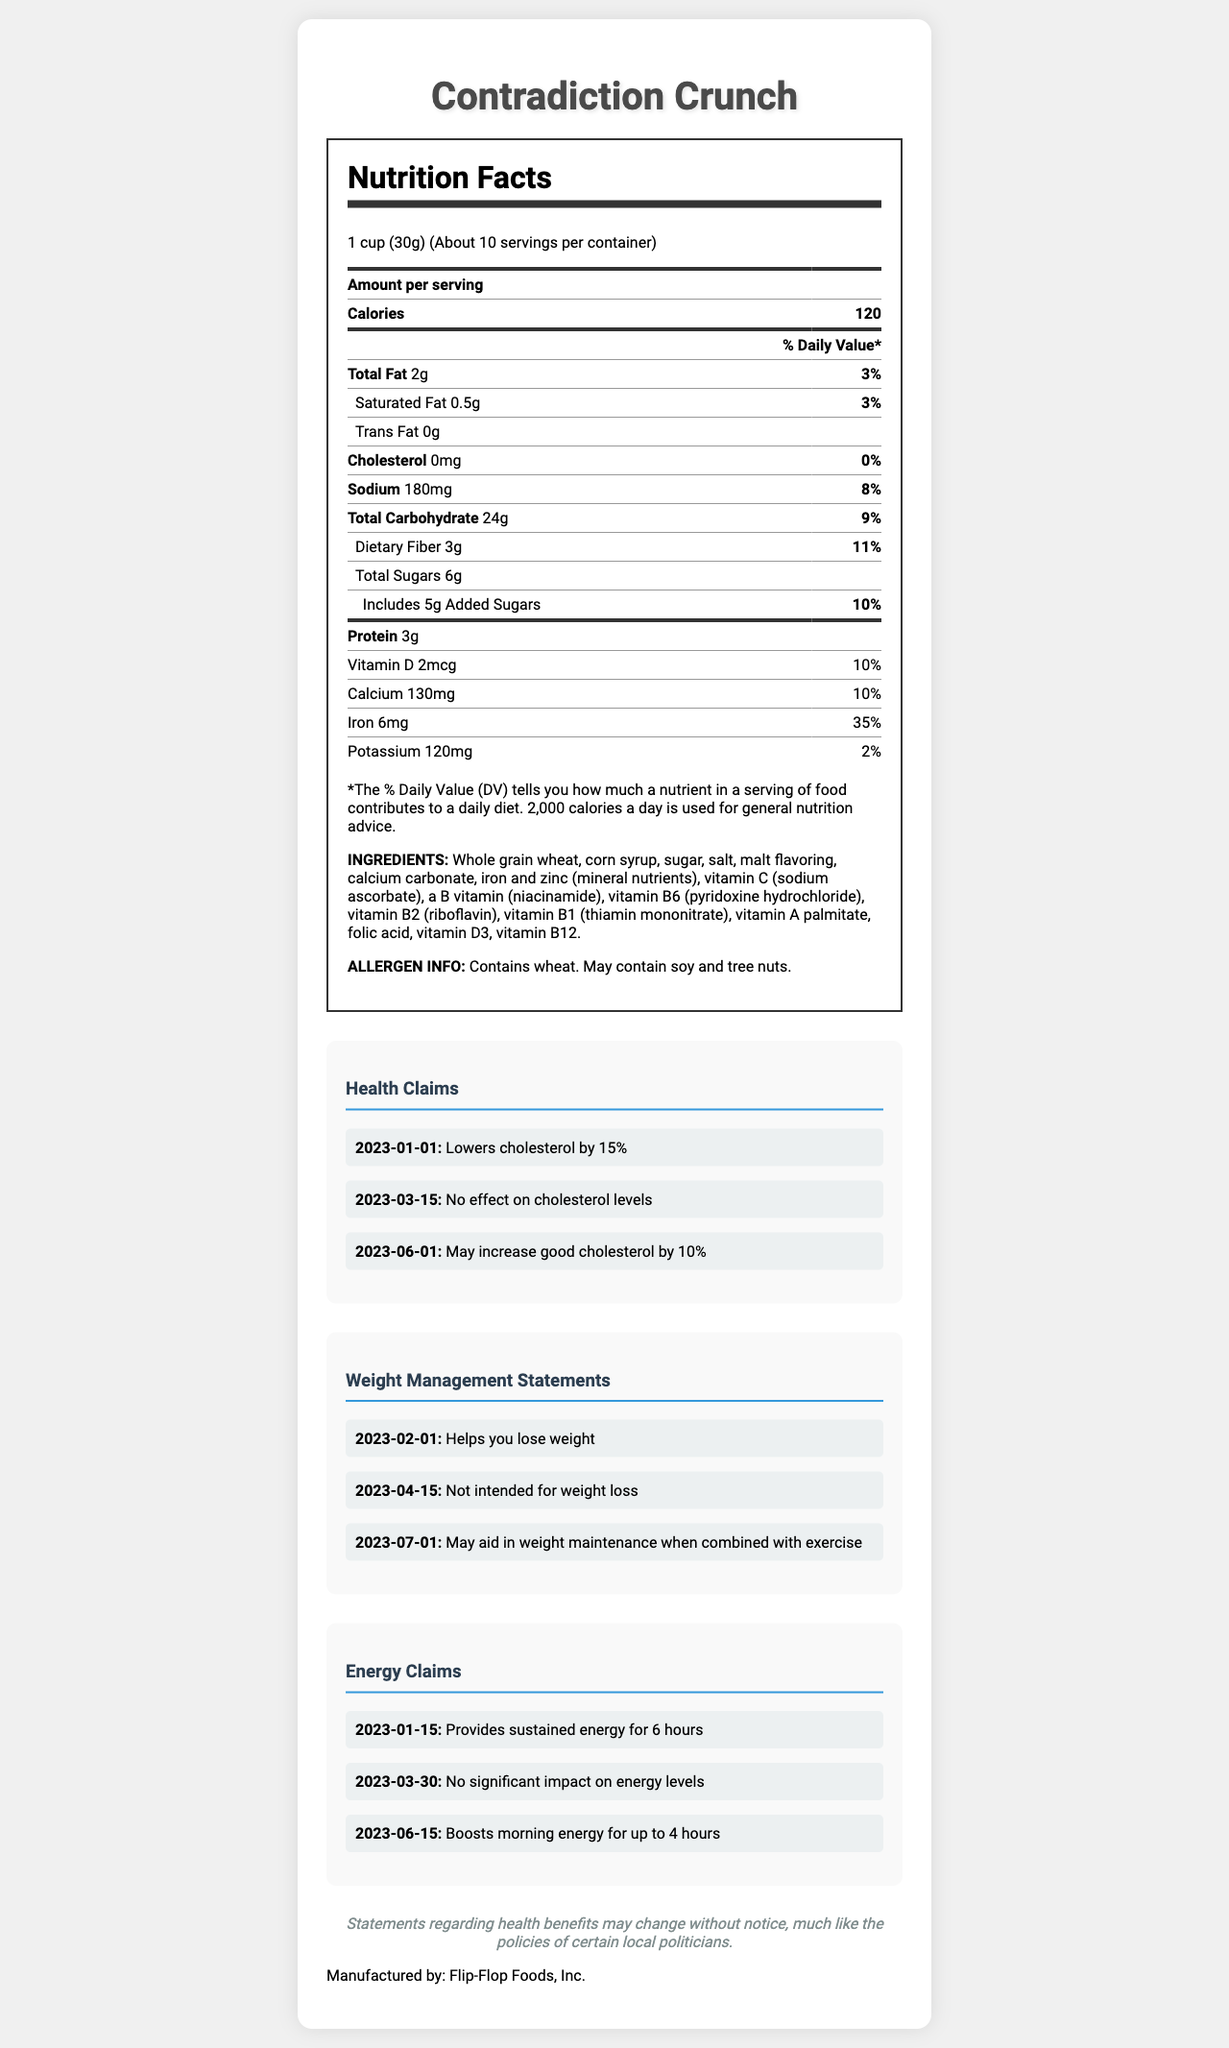what is the serving size of Contradiction Crunch? The serving size is stated in the first section of the nutrition facts, which mentions "1 cup (30g)".
Answer: 1 cup (30g) how many total calories are in one serving? The document specifies that there are 120 calories per serving.
Answer: 120 how many servings are in the container? The serving information states that there are "About 10" servings per container.
Answer: About 10 what is the amount of added sugars per serving? The nutrition label lists 5g as the amount of added sugars per serving.
Answer: 5g what is the daily value percentage of iron per serving? The daily value percentage for iron is listed as 35%.
Answer: 35% does the cereal contain any common allergens? The allergen info states that the cereal contains wheat and may contain soy and tree nuts.
Answer: Yes list all the vitamins and minerals mentioned on the label The vitamins and minerals listed under the nutrition facts are Vitamin D, Calcium, Iron, and Potassium.
Answer: Vitamin D, Calcium, Iron, Potassium what is the range of health claims made throughout the document? The document lists health claims ranging from "Lowers cholesterol by 15%" to "May increase good cholesterol by 10%".
Answer: Lowers cholesterol by 15% to May increase good cholesterol by 10% how has the manufacturer's energy claim changed over time? A. Provides sustained energy for 6 hours to Boosts morning energy for up to 4 hours B. No effect on energy levels to Provides sustained energy for 6 hours C. Boosts morning energy for up to 4 hours to Provides sustained energy for 6 hours The claims transitioned from "Provides sustained energy for 6 hours" (2023-01-15) to "No significant impact on energy levels" (2023-03-30) and then to "Boosts morning energy for up to 4 hours" (2023-06-15).
Answer: A which of the following statements is a weight management claim made in April 2023? i. Helps you lose weight ii. Not intended for weight loss iii. May aid in weight maintenance when combined with exercise The weight management claim made in April 2023 is "Not intended for weight loss".
Answer: ii does the cereal help reduce cholesterol? The health claims are contradictory, with statements claiming it "Lowers cholesterol by 15%", "No effect on cholesterol levels", and "May increase good cholesterol by 10%".
Answer: Cannot be determined is there any cholesterol in the cereal? The nutrition label states that there is 0mg of cholesterol per serving.
Answer: No summarize the main points of the Contradiction Crunch nutrition facts label The summary covers the main nutritional contents, changing claims about health benefits, allergens, manufacturer, and disclaimer found in the document.
Answer: The Contradiction Crunch cereal contains 120 calories per 1 cup serving, with notable nutrients including 2g of total fat, 24g of carbohydrates, 3g of dietary fiber, 6g of total sugars, and 3g of protein. It has vitamins and minerals such as Vitamin D (2mcg), Calcium (130mg), Iron (6mg), and Potassium (120mg). The cereal's packaging includes various health, weight management, and energy claims which have changed over time, reflecting contradictory statements about its benefits. Ingredients listed include whole grain wheat, corn syrup, various vitamins, and minerals, with allergen info noting the presence of wheat, and possible soy and tree nuts. There is a disclaimer that health benefit statements may change without notice. The product is manufactured by Flip-Flop Foods, Inc. 